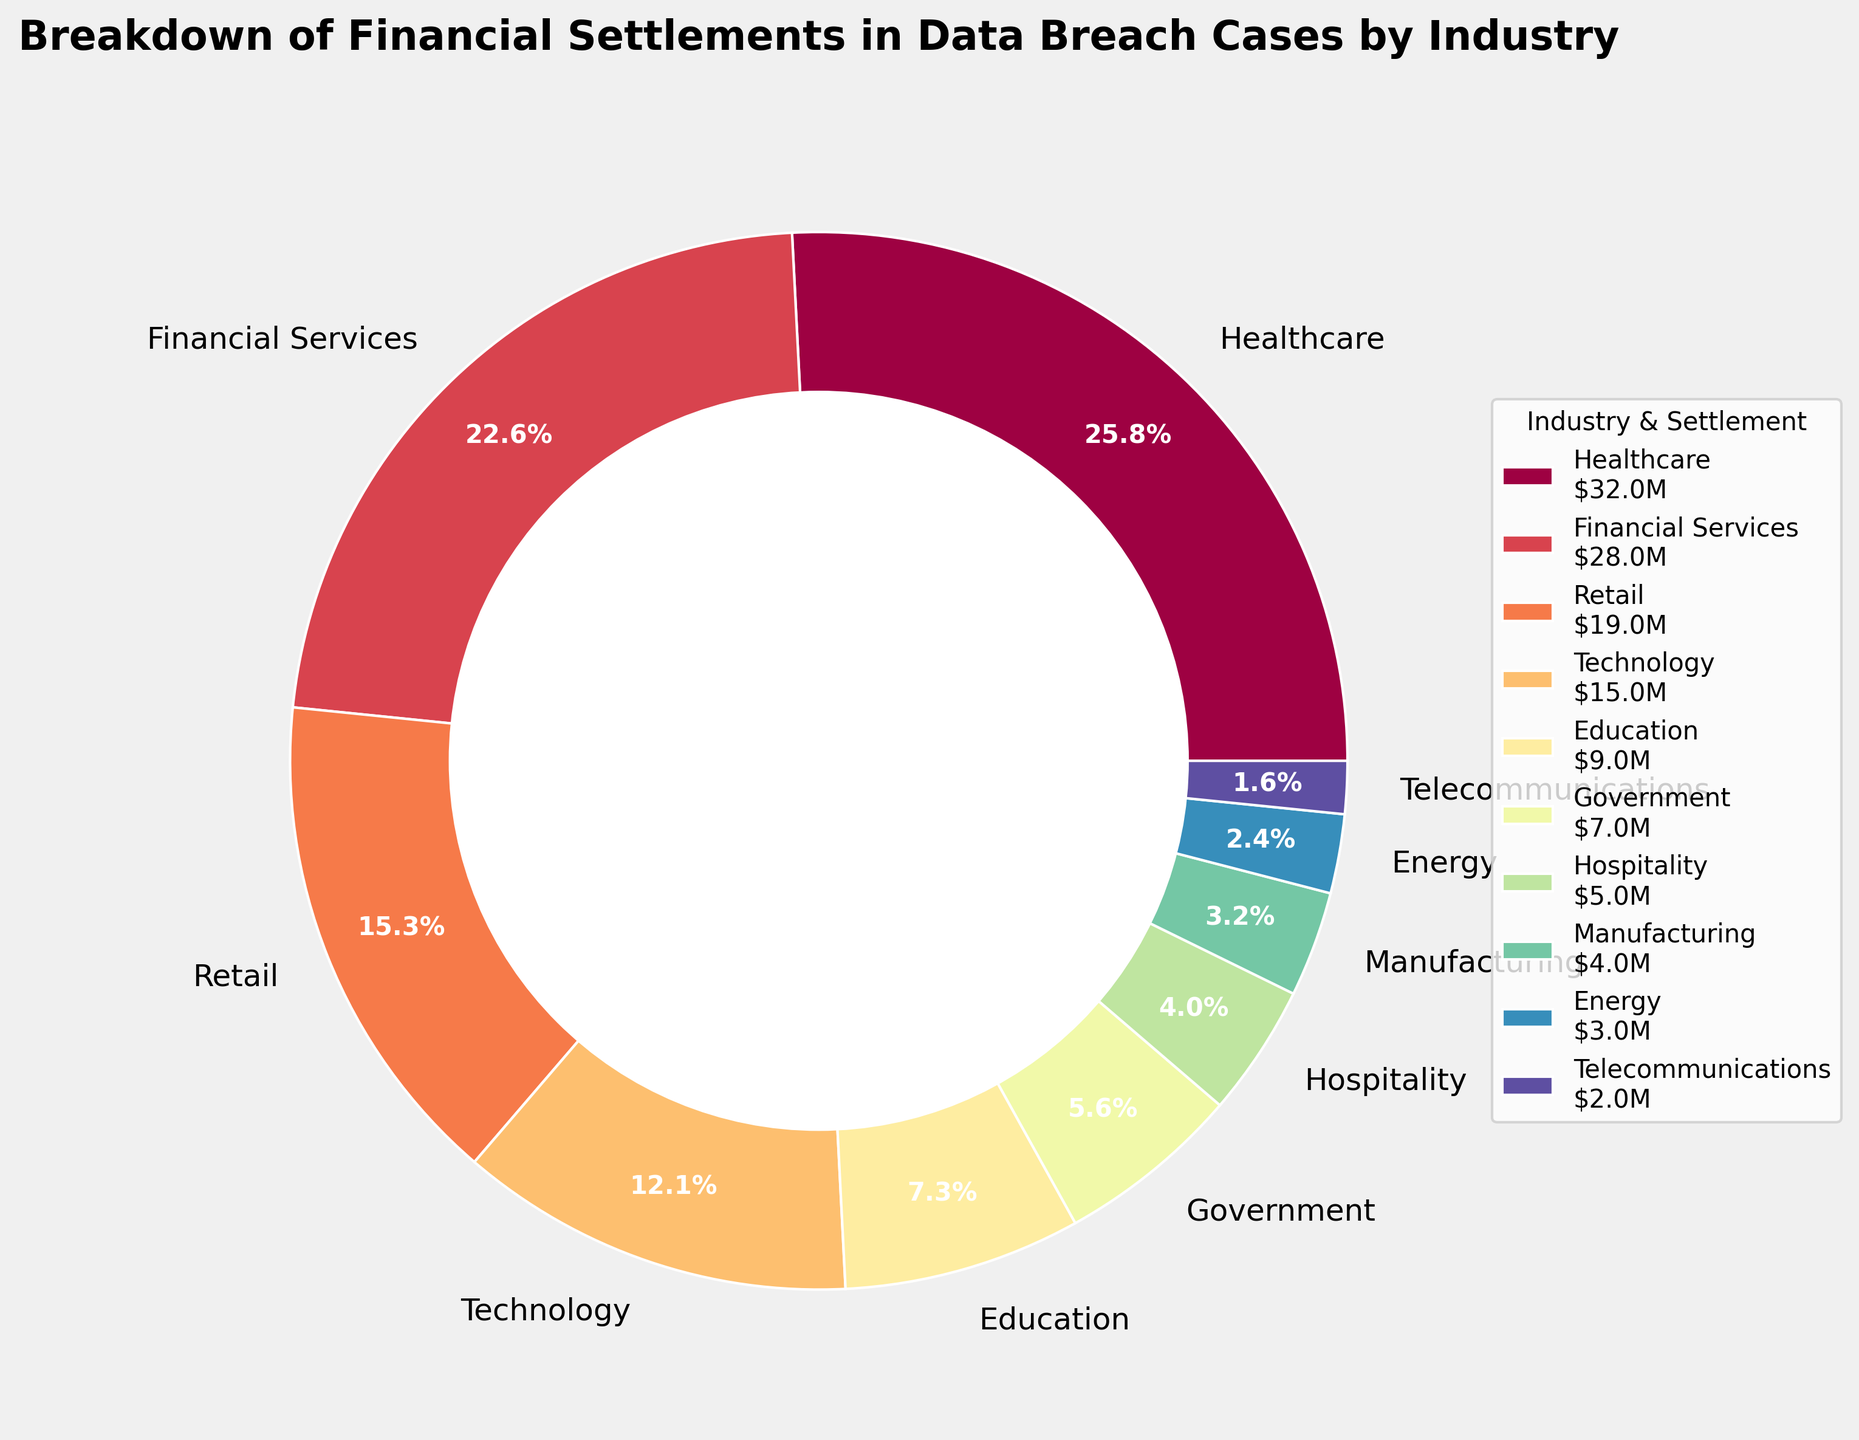What percentage of the total settlements is attributed to the healthcare industry? The healthcare industry's proportion of the total settlement is represented by the slice attributed to it. According to the figure, this is 32.0%.
Answer: 32.0% Which industry has the second-largest settlement amount, and what is the amount? The second-largest settlement amount is shown by the slice representing the financial services industry. The amount is displayed in the legend as $28.0M.
Answer: Financial Services, $28.0M How much more is the settlement amount for healthcare than for technology? The settlement amount for healthcare is $32.0M, and for technology, it is $15.0M. The difference is $32.0M - $15.0M.
Answer: $17.0M What is the combined percentage of the settlement amounts for the retail and education industries? The percentage for retail is 19.0%, and for education, it is 9.0%. Summing these gives 19.0% + 9.0%.
Answer: 28.0% Which industries have settlement amounts less than $10 million? According to the legend and pie chart, education, government, hospitality, manufacturing, energy, and telecommunications have settlement amounts less than $10 million.
Answer: Education, Government, Hospitality, Manufacturing, Energy, Telecommunications What is the percentage difference between the settlement amounts for healthcare and manufacturing industries? The percentage for healthcare is 32.0%, and for manufacturing, it is 4.0%. The difference is 32.0% - 4.0%.
Answer: 28.0% Compare the settlement amounts for the energy and telecommunications industries. Which is higher, and by how much? The energy industry has a settlement amount of $3.0M and telecommunications have $2.0M. The difference is $3.0M - $2.0M, and energy is higher.
Answer: Energy by $1.0M Name three industries with the smallest settlement amounts and their corresponding figures. The three industries with the smallest settlements are telecommunications ($2.0M), energy ($3.0M), and manufacturing ($4.0M) as indicated by the pie chart and legend.
Answer: Telecommunications ($2.0M), Energy ($3.0M), Manufacturing ($4.0M) What is the total settlement amount for the top three industries? The top three industries by settlement amount are healthcare ($32.0M), financial services ($28.0M), and retail ($19.0M). Summing these gives $32.0M + $28.0M + $19.0M.
Answer: $79.0M 